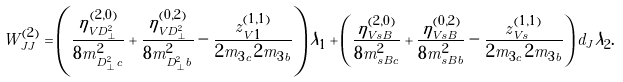Convert formula to latex. <formula><loc_0><loc_0><loc_500><loc_500>W ^ { ( 2 ) } _ { J J } = \left ( \frac { \eta _ { V D _ { \perp } ^ { 2 } } ^ { ( 2 , 0 ) } } { 8 m _ { D _ { \perp } ^ { 2 } c } ^ { 2 } } + \frac { \eta _ { V D _ { \perp } ^ { 2 } } ^ { ( 0 , 2 ) } } { 8 m _ { D _ { \perp } ^ { 2 } b } ^ { 2 } } - \frac { z ^ { ( 1 , 1 ) } _ { V 1 } } { 2 m _ { 3 c } \, 2 m _ { 3 b } } \right ) \lambda _ { 1 } + \left ( \frac { \eta _ { V s B } ^ { ( 2 , 0 ) } } { 8 m _ { s B c } ^ { 2 } } + \frac { \eta _ { V s B } ^ { ( 0 , 2 ) } } { 8 m _ { s B b } ^ { 2 } } - \frac { z ^ { ( 1 , 1 ) } _ { V s } } { 2 m _ { 3 c } \, 2 m _ { 3 b } } \right ) d _ { J } \lambda _ { 2 } .</formula> 